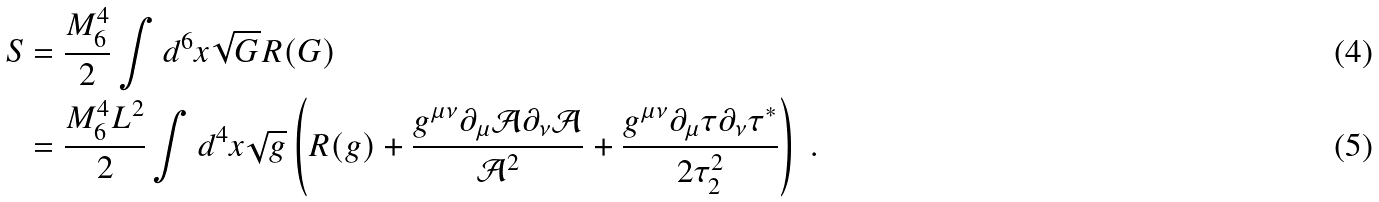<formula> <loc_0><loc_0><loc_500><loc_500>S & = \frac { M _ { 6 } ^ { 4 } } { 2 } \int d ^ { 6 } x \sqrt { G } R ( G ) \\ & = \frac { M ^ { 4 } _ { 6 } L ^ { 2 } } { 2 } \int d ^ { 4 } x \sqrt { g } \left ( R ( g ) + \frac { g ^ { \mu \nu } \partial _ { \mu } \mathcal { A } \partial _ { \nu } \mathcal { A } } { \mathcal { A } ^ { 2 } } + \frac { g ^ { \mu \nu } \partial _ { \mu } \tau \partial _ { \nu } \tau ^ { * } } { 2 \mathcal { \tau } _ { 2 } ^ { 2 } } \right ) \ .</formula> 